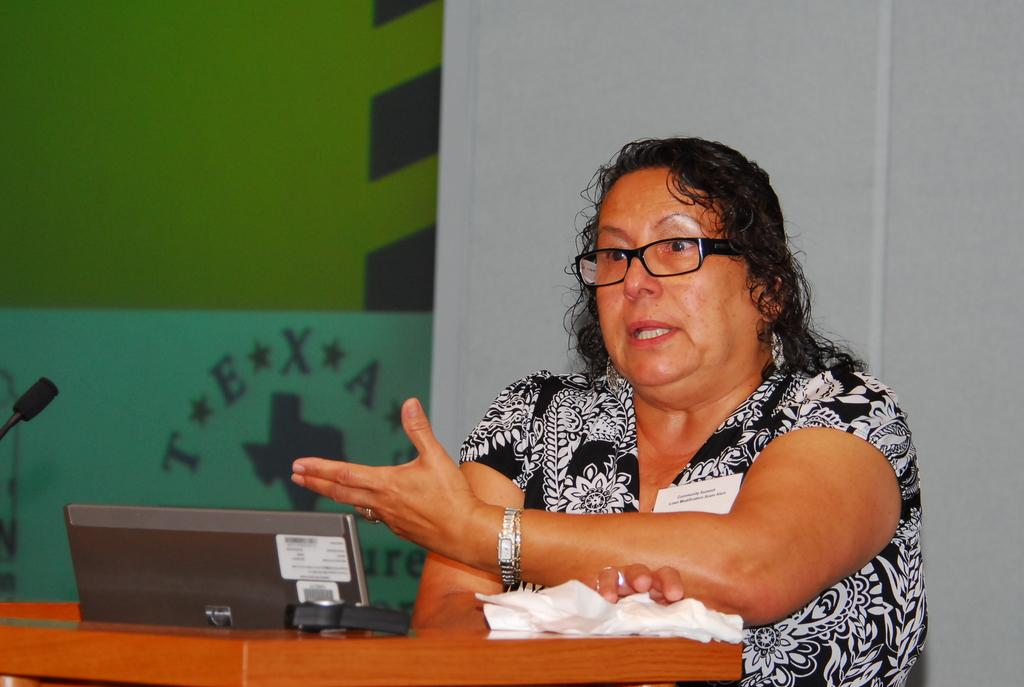What is located in the foreground of the picture? There is a table in the foreground of the picture. What is on the table? There is a desktop on the table. Who is present in the foreground of the picture? A woman is present in the foreground of the picture. What is the woman doing? The woman is talking. What can be seen on the left side of the picture? There is a mic on the left side of the picture. What is visible in the background of the picture? There is a wall and glass in the background of the picture. What type of pancake is being prepared by the laborer in the image? There is no laborer or pancake present in the image. What type of wall is visible in the background of the image? The type of wall cannot be determined from the image, as only the presence of a wall is mentioned. 